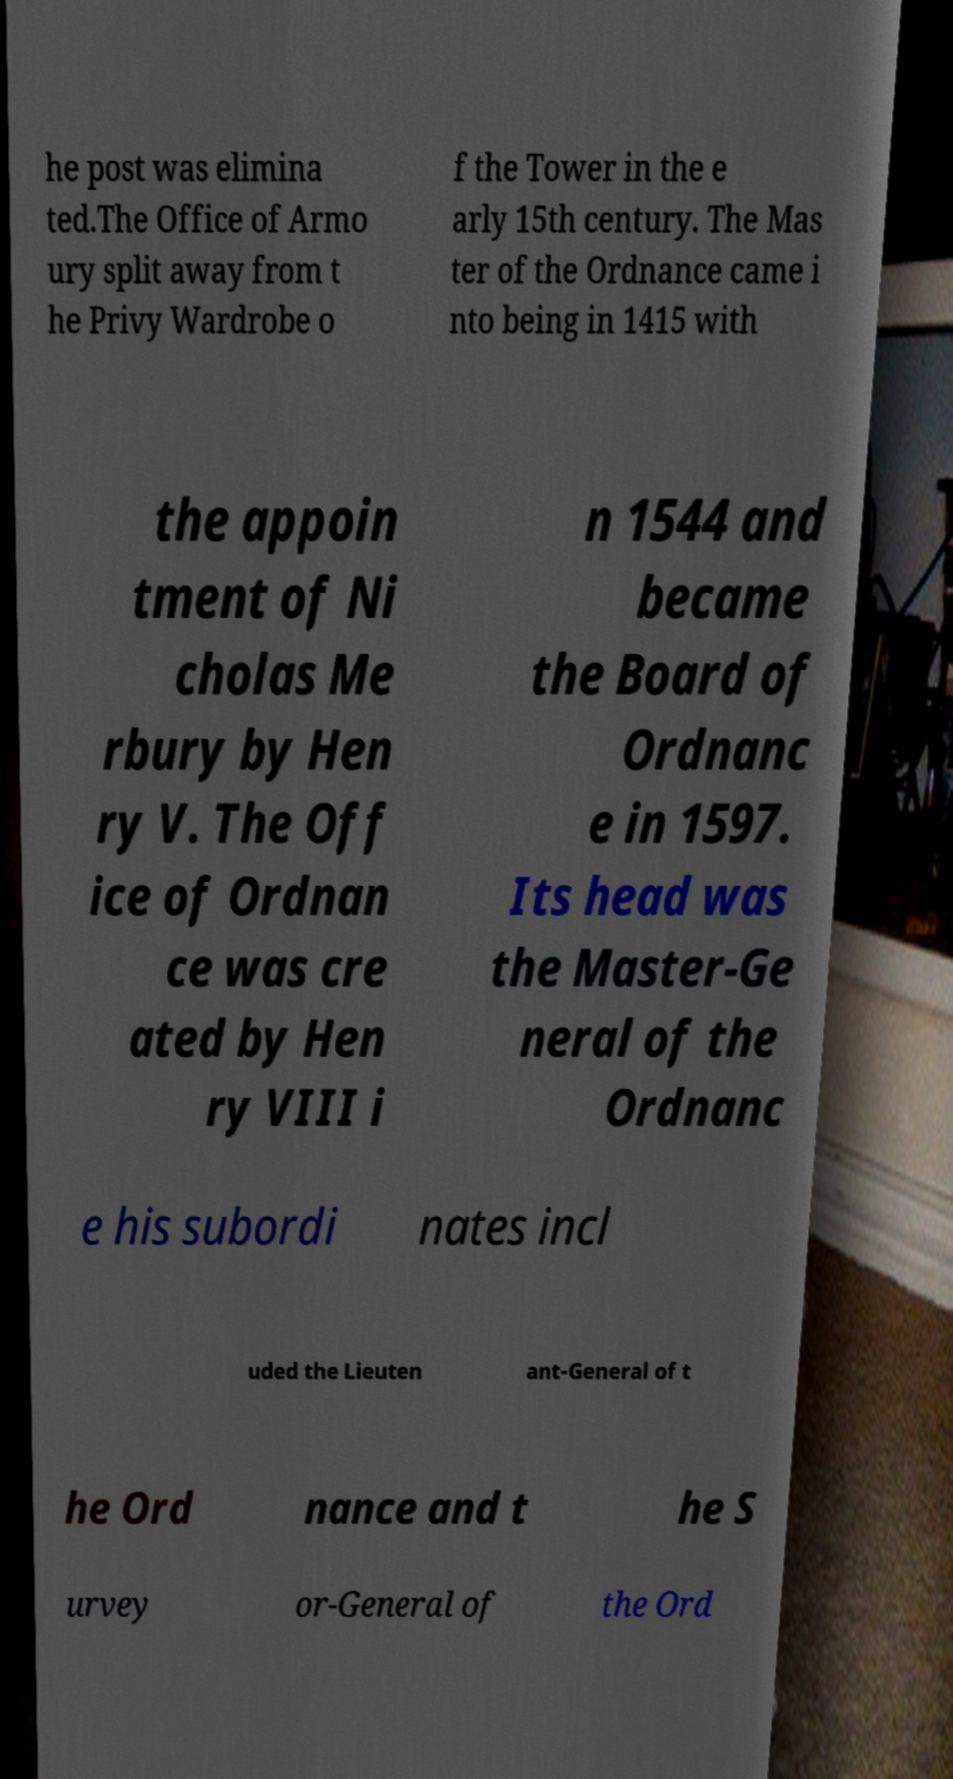Can you read and provide the text displayed in the image?This photo seems to have some interesting text. Can you extract and type it out for me? he post was elimina ted.The Office of Armo ury split away from t he Privy Wardrobe o f the Tower in the e arly 15th century. The Mas ter of the Ordnance came i nto being in 1415 with the appoin tment of Ni cholas Me rbury by Hen ry V. The Off ice of Ordnan ce was cre ated by Hen ry VIII i n 1544 and became the Board of Ordnanc e in 1597. Its head was the Master-Ge neral of the Ordnanc e his subordi nates incl uded the Lieuten ant-General of t he Ord nance and t he S urvey or-General of the Ord 